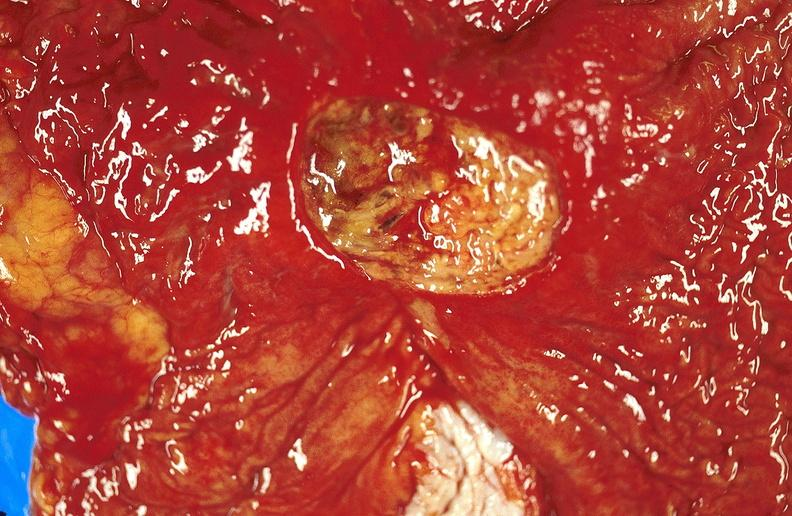does fibrinous peritonitis show gastric ulcer?
Answer the question using a single word or phrase. No 